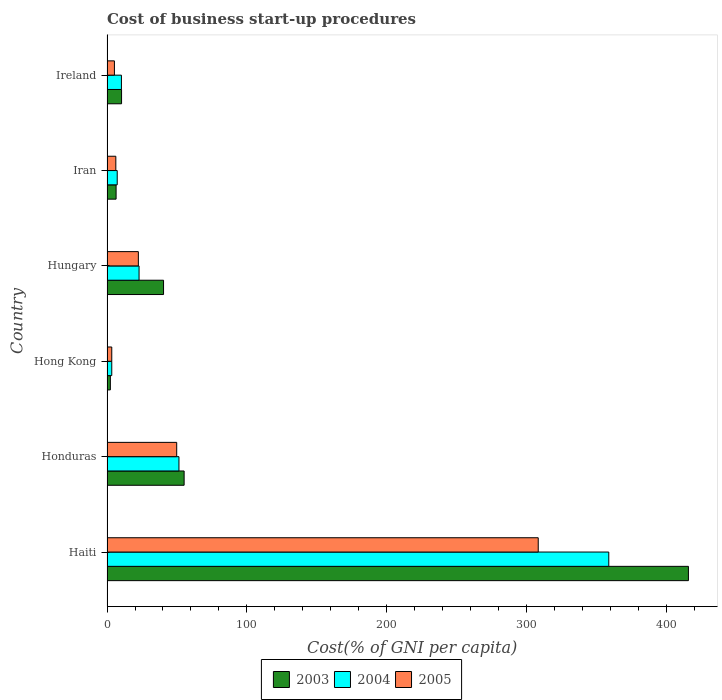How many different coloured bars are there?
Provide a short and direct response. 3. How many bars are there on the 5th tick from the bottom?
Your answer should be very brief. 3. What is the label of the 5th group of bars from the top?
Offer a very short reply. Honduras. In how many cases, is the number of bars for a given country not equal to the number of legend labels?
Keep it short and to the point. 0. Across all countries, what is the maximum cost of business start-up procedures in 2004?
Offer a terse response. 358.5. Across all countries, what is the minimum cost of business start-up procedures in 2003?
Provide a short and direct response. 2.4. In which country was the cost of business start-up procedures in 2005 maximum?
Ensure brevity in your answer.  Haiti. In which country was the cost of business start-up procedures in 2005 minimum?
Offer a terse response. Hong Kong. What is the total cost of business start-up procedures in 2003 in the graph?
Ensure brevity in your answer.  530.2. What is the difference between the cost of business start-up procedures in 2004 in Haiti and that in Honduras?
Provide a short and direct response. 307.1. What is the difference between the cost of business start-up procedures in 2004 in Honduras and the cost of business start-up procedures in 2003 in Hong Kong?
Provide a short and direct response. 49. What is the average cost of business start-up procedures in 2004 per country?
Offer a terse response. 75.63. What is the difference between the cost of business start-up procedures in 2005 and cost of business start-up procedures in 2003 in Honduras?
Keep it short and to the point. -5.3. In how many countries, is the cost of business start-up procedures in 2005 greater than 220 %?
Make the answer very short. 1. What is the ratio of the cost of business start-up procedures in 2004 in Hong Kong to that in Ireland?
Give a very brief answer. 0.33. What is the difference between the highest and the second highest cost of business start-up procedures in 2003?
Your answer should be very brief. 360.3. What is the difference between the highest and the lowest cost of business start-up procedures in 2005?
Give a very brief answer. 304.7. In how many countries, is the cost of business start-up procedures in 2003 greater than the average cost of business start-up procedures in 2003 taken over all countries?
Give a very brief answer. 1. Is the sum of the cost of business start-up procedures in 2003 in Haiti and Hungary greater than the maximum cost of business start-up procedures in 2005 across all countries?
Offer a very short reply. Yes. What does the 3rd bar from the top in Iran represents?
Keep it short and to the point. 2003. What does the 3rd bar from the bottom in Hong Kong represents?
Offer a very short reply. 2005. Is it the case that in every country, the sum of the cost of business start-up procedures in 2003 and cost of business start-up procedures in 2004 is greater than the cost of business start-up procedures in 2005?
Offer a very short reply. Yes. Does the graph contain any zero values?
Provide a short and direct response. No. How many legend labels are there?
Offer a terse response. 3. What is the title of the graph?
Your response must be concise. Cost of business start-up procedures. Does "1971" appear as one of the legend labels in the graph?
Make the answer very short. No. What is the label or title of the X-axis?
Ensure brevity in your answer.  Cost(% of GNI per capita). What is the Cost(% of GNI per capita) of 2003 in Haiti?
Make the answer very short. 415.4. What is the Cost(% of GNI per capita) of 2004 in Haiti?
Keep it short and to the point. 358.5. What is the Cost(% of GNI per capita) in 2005 in Haiti?
Offer a terse response. 308.1. What is the Cost(% of GNI per capita) of 2003 in Honduras?
Give a very brief answer. 55.1. What is the Cost(% of GNI per capita) in 2004 in Honduras?
Give a very brief answer. 51.4. What is the Cost(% of GNI per capita) of 2005 in Honduras?
Your answer should be compact. 49.8. What is the Cost(% of GNI per capita) in 2003 in Hong Kong?
Make the answer very short. 2.4. What is the Cost(% of GNI per capita) of 2003 in Hungary?
Your answer should be compact. 40.4. What is the Cost(% of GNI per capita) of 2004 in Hungary?
Your answer should be very brief. 22.9. What is the Cost(% of GNI per capita) of 2005 in Hungary?
Provide a succinct answer. 22.4. What is the Cost(% of GNI per capita) of 2004 in Iran?
Ensure brevity in your answer.  7.3. What is the Cost(% of GNI per capita) in 2003 in Ireland?
Provide a succinct answer. 10.4. What is the Cost(% of GNI per capita) of 2005 in Ireland?
Provide a succinct answer. 5.3. Across all countries, what is the maximum Cost(% of GNI per capita) in 2003?
Offer a terse response. 415.4. Across all countries, what is the maximum Cost(% of GNI per capita) in 2004?
Give a very brief answer. 358.5. Across all countries, what is the maximum Cost(% of GNI per capita) in 2005?
Provide a short and direct response. 308.1. Across all countries, what is the minimum Cost(% of GNI per capita) in 2004?
Offer a terse response. 3.4. What is the total Cost(% of GNI per capita) of 2003 in the graph?
Provide a succinct answer. 530.2. What is the total Cost(% of GNI per capita) in 2004 in the graph?
Your response must be concise. 453.8. What is the total Cost(% of GNI per capita) of 2005 in the graph?
Make the answer very short. 395.3. What is the difference between the Cost(% of GNI per capita) of 2003 in Haiti and that in Honduras?
Provide a succinct answer. 360.3. What is the difference between the Cost(% of GNI per capita) of 2004 in Haiti and that in Honduras?
Your response must be concise. 307.1. What is the difference between the Cost(% of GNI per capita) of 2005 in Haiti and that in Honduras?
Ensure brevity in your answer.  258.3. What is the difference between the Cost(% of GNI per capita) in 2003 in Haiti and that in Hong Kong?
Ensure brevity in your answer.  413. What is the difference between the Cost(% of GNI per capita) of 2004 in Haiti and that in Hong Kong?
Your answer should be compact. 355.1. What is the difference between the Cost(% of GNI per capita) of 2005 in Haiti and that in Hong Kong?
Your answer should be very brief. 304.7. What is the difference between the Cost(% of GNI per capita) of 2003 in Haiti and that in Hungary?
Make the answer very short. 375. What is the difference between the Cost(% of GNI per capita) of 2004 in Haiti and that in Hungary?
Offer a terse response. 335.6. What is the difference between the Cost(% of GNI per capita) in 2005 in Haiti and that in Hungary?
Provide a succinct answer. 285.7. What is the difference between the Cost(% of GNI per capita) of 2003 in Haiti and that in Iran?
Offer a very short reply. 408.9. What is the difference between the Cost(% of GNI per capita) in 2004 in Haiti and that in Iran?
Your response must be concise. 351.2. What is the difference between the Cost(% of GNI per capita) in 2005 in Haiti and that in Iran?
Your response must be concise. 301.8. What is the difference between the Cost(% of GNI per capita) of 2003 in Haiti and that in Ireland?
Your answer should be very brief. 405. What is the difference between the Cost(% of GNI per capita) of 2004 in Haiti and that in Ireland?
Provide a short and direct response. 348.2. What is the difference between the Cost(% of GNI per capita) of 2005 in Haiti and that in Ireland?
Your answer should be compact. 302.8. What is the difference between the Cost(% of GNI per capita) in 2003 in Honduras and that in Hong Kong?
Keep it short and to the point. 52.7. What is the difference between the Cost(% of GNI per capita) in 2004 in Honduras and that in Hong Kong?
Provide a short and direct response. 48. What is the difference between the Cost(% of GNI per capita) of 2005 in Honduras and that in Hong Kong?
Your answer should be compact. 46.4. What is the difference between the Cost(% of GNI per capita) in 2003 in Honduras and that in Hungary?
Your answer should be compact. 14.7. What is the difference between the Cost(% of GNI per capita) of 2004 in Honduras and that in Hungary?
Your response must be concise. 28.5. What is the difference between the Cost(% of GNI per capita) in 2005 in Honduras and that in Hungary?
Give a very brief answer. 27.4. What is the difference between the Cost(% of GNI per capita) of 2003 in Honduras and that in Iran?
Make the answer very short. 48.6. What is the difference between the Cost(% of GNI per capita) in 2004 in Honduras and that in Iran?
Keep it short and to the point. 44.1. What is the difference between the Cost(% of GNI per capita) of 2005 in Honduras and that in Iran?
Make the answer very short. 43.5. What is the difference between the Cost(% of GNI per capita) in 2003 in Honduras and that in Ireland?
Your response must be concise. 44.7. What is the difference between the Cost(% of GNI per capita) of 2004 in Honduras and that in Ireland?
Offer a terse response. 41.1. What is the difference between the Cost(% of GNI per capita) of 2005 in Honduras and that in Ireland?
Offer a very short reply. 44.5. What is the difference between the Cost(% of GNI per capita) of 2003 in Hong Kong and that in Hungary?
Offer a terse response. -38. What is the difference between the Cost(% of GNI per capita) of 2004 in Hong Kong and that in Hungary?
Offer a very short reply. -19.5. What is the difference between the Cost(% of GNI per capita) of 2005 in Hong Kong and that in Iran?
Your answer should be very brief. -2.9. What is the difference between the Cost(% of GNI per capita) of 2003 in Hong Kong and that in Ireland?
Offer a terse response. -8. What is the difference between the Cost(% of GNI per capita) of 2004 in Hong Kong and that in Ireland?
Provide a short and direct response. -6.9. What is the difference between the Cost(% of GNI per capita) in 2005 in Hong Kong and that in Ireland?
Offer a terse response. -1.9. What is the difference between the Cost(% of GNI per capita) of 2003 in Hungary and that in Iran?
Your answer should be compact. 33.9. What is the difference between the Cost(% of GNI per capita) in 2005 in Hungary and that in Iran?
Make the answer very short. 16.1. What is the difference between the Cost(% of GNI per capita) in 2005 in Hungary and that in Ireland?
Your answer should be very brief. 17.1. What is the difference between the Cost(% of GNI per capita) in 2005 in Iran and that in Ireland?
Provide a short and direct response. 1. What is the difference between the Cost(% of GNI per capita) of 2003 in Haiti and the Cost(% of GNI per capita) of 2004 in Honduras?
Provide a short and direct response. 364. What is the difference between the Cost(% of GNI per capita) in 2003 in Haiti and the Cost(% of GNI per capita) in 2005 in Honduras?
Offer a very short reply. 365.6. What is the difference between the Cost(% of GNI per capita) in 2004 in Haiti and the Cost(% of GNI per capita) in 2005 in Honduras?
Ensure brevity in your answer.  308.7. What is the difference between the Cost(% of GNI per capita) of 2003 in Haiti and the Cost(% of GNI per capita) of 2004 in Hong Kong?
Make the answer very short. 412. What is the difference between the Cost(% of GNI per capita) of 2003 in Haiti and the Cost(% of GNI per capita) of 2005 in Hong Kong?
Provide a succinct answer. 412. What is the difference between the Cost(% of GNI per capita) of 2004 in Haiti and the Cost(% of GNI per capita) of 2005 in Hong Kong?
Your answer should be very brief. 355.1. What is the difference between the Cost(% of GNI per capita) in 2003 in Haiti and the Cost(% of GNI per capita) in 2004 in Hungary?
Make the answer very short. 392.5. What is the difference between the Cost(% of GNI per capita) in 2003 in Haiti and the Cost(% of GNI per capita) in 2005 in Hungary?
Keep it short and to the point. 393. What is the difference between the Cost(% of GNI per capita) in 2004 in Haiti and the Cost(% of GNI per capita) in 2005 in Hungary?
Make the answer very short. 336.1. What is the difference between the Cost(% of GNI per capita) of 2003 in Haiti and the Cost(% of GNI per capita) of 2004 in Iran?
Give a very brief answer. 408.1. What is the difference between the Cost(% of GNI per capita) in 2003 in Haiti and the Cost(% of GNI per capita) in 2005 in Iran?
Give a very brief answer. 409.1. What is the difference between the Cost(% of GNI per capita) of 2004 in Haiti and the Cost(% of GNI per capita) of 2005 in Iran?
Keep it short and to the point. 352.2. What is the difference between the Cost(% of GNI per capita) in 2003 in Haiti and the Cost(% of GNI per capita) in 2004 in Ireland?
Ensure brevity in your answer.  405.1. What is the difference between the Cost(% of GNI per capita) in 2003 in Haiti and the Cost(% of GNI per capita) in 2005 in Ireland?
Ensure brevity in your answer.  410.1. What is the difference between the Cost(% of GNI per capita) of 2004 in Haiti and the Cost(% of GNI per capita) of 2005 in Ireland?
Offer a very short reply. 353.2. What is the difference between the Cost(% of GNI per capita) of 2003 in Honduras and the Cost(% of GNI per capita) of 2004 in Hong Kong?
Your response must be concise. 51.7. What is the difference between the Cost(% of GNI per capita) of 2003 in Honduras and the Cost(% of GNI per capita) of 2005 in Hong Kong?
Offer a very short reply. 51.7. What is the difference between the Cost(% of GNI per capita) in 2004 in Honduras and the Cost(% of GNI per capita) in 2005 in Hong Kong?
Keep it short and to the point. 48. What is the difference between the Cost(% of GNI per capita) of 2003 in Honduras and the Cost(% of GNI per capita) of 2004 in Hungary?
Your answer should be compact. 32.2. What is the difference between the Cost(% of GNI per capita) in 2003 in Honduras and the Cost(% of GNI per capita) in 2005 in Hungary?
Provide a succinct answer. 32.7. What is the difference between the Cost(% of GNI per capita) in 2003 in Honduras and the Cost(% of GNI per capita) in 2004 in Iran?
Offer a very short reply. 47.8. What is the difference between the Cost(% of GNI per capita) of 2003 in Honduras and the Cost(% of GNI per capita) of 2005 in Iran?
Your response must be concise. 48.8. What is the difference between the Cost(% of GNI per capita) in 2004 in Honduras and the Cost(% of GNI per capita) in 2005 in Iran?
Ensure brevity in your answer.  45.1. What is the difference between the Cost(% of GNI per capita) of 2003 in Honduras and the Cost(% of GNI per capita) of 2004 in Ireland?
Give a very brief answer. 44.8. What is the difference between the Cost(% of GNI per capita) in 2003 in Honduras and the Cost(% of GNI per capita) in 2005 in Ireland?
Make the answer very short. 49.8. What is the difference between the Cost(% of GNI per capita) in 2004 in Honduras and the Cost(% of GNI per capita) in 2005 in Ireland?
Make the answer very short. 46.1. What is the difference between the Cost(% of GNI per capita) in 2003 in Hong Kong and the Cost(% of GNI per capita) in 2004 in Hungary?
Make the answer very short. -20.5. What is the difference between the Cost(% of GNI per capita) in 2003 in Hong Kong and the Cost(% of GNI per capita) in 2005 in Hungary?
Your response must be concise. -20. What is the difference between the Cost(% of GNI per capita) of 2003 in Hong Kong and the Cost(% of GNI per capita) of 2004 in Iran?
Make the answer very short. -4.9. What is the difference between the Cost(% of GNI per capita) of 2004 in Hong Kong and the Cost(% of GNI per capita) of 2005 in Iran?
Ensure brevity in your answer.  -2.9. What is the difference between the Cost(% of GNI per capita) in 2003 in Hong Kong and the Cost(% of GNI per capita) in 2004 in Ireland?
Give a very brief answer. -7.9. What is the difference between the Cost(% of GNI per capita) of 2003 in Hong Kong and the Cost(% of GNI per capita) of 2005 in Ireland?
Ensure brevity in your answer.  -2.9. What is the difference between the Cost(% of GNI per capita) of 2004 in Hong Kong and the Cost(% of GNI per capita) of 2005 in Ireland?
Your answer should be compact. -1.9. What is the difference between the Cost(% of GNI per capita) in 2003 in Hungary and the Cost(% of GNI per capita) in 2004 in Iran?
Give a very brief answer. 33.1. What is the difference between the Cost(% of GNI per capita) in 2003 in Hungary and the Cost(% of GNI per capita) in 2005 in Iran?
Provide a succinct answer. 34.1. What is the difference between the Cost(% of GNI per capita) of 2004 in Hungary and the Cost(% of GNI per capita) of 2005 in Iran?
Provide a succinct answer. 16.6. What is the difference between the Cost(% of GNI per capita) of 2003 in Hungary and the Cost(% of GNI per capita) of 2004 in Ireland?
Offer a very short reply. 30.1. What is the difference between the Cost(% of GNI per capita) in 2003 in Hungary and the Cost(% of GNI per capita) in 2005 in Ireland?
Your response must be concise. 35.1. What is the difference between the Cost(% of GNI per capita) of 2004 in Hungary and the Cost(% of GNI per capita) of 2005 in Ireland?
Your response must be concise. 17.6. What is the difference between the Cost(% of GNI per capita) of 2003 in Iran and the Cost(% of GNI per capita) of 2004 in Ireland?
Make the answer very short. -3.8. What is the difference between the Cost(% of GNI per capita) of 2004 in Iran and the Cost(% of GNI per capita) of 2005 in Ireland?
Provide a succinct answer. 2. What is the average Cost(% of GNI per capita) of 2003 per country?
Provide a short and direct response. 88.37. What is the average Cost(% of GNI per capita) in 2004 per country?
Provide a succinct answer. 75.63. What is the average Cost(% of GNI per capita) in 2005 per country?
Provide a short and direct response. 65.88. What is the difference between the Cost(% of GNI per capita) of 2003 and Cost(% of GNI per capita) of 2004 in Haiti?
Keep it short and to the point. 56.9. What is the difference between the Cost(% of GNI per capita) in 2003 and Cost(% of GNI per capita) in 2005 in Haiti?
Ensure brevity in your answer.  107.3. What is the difference between the Cost(% of GNI per capita) in 2004 and Cost(% of GNI per capita) in 2005 in Haiti?
Your answer should be very brief. 50.4. What is the difference between the Cost(% of GNI per capita) of 2003 and Cost(% of GNI per capita) of 2004 in Honduras?
Provide a succinct answer. 3.7. What is the difference between the Cost(% of GNI per capita) of 2003 and Cost(% of GNI per capita) of 2005 in Hong Kong?
Your response must be concise. -1. What is the difference between the Cost(% of GNI per capita) in 2003 and Cost(% of GNI per capita) in 2004 in Iran?
Make the answer very short. -0.8. What is the difference between the Cost(% of GNI per capita) in 2003 and Cost(% of GNI per capita) in 2005 in Iran?
Give a very brief answer. 0.2. What is the difference between the Cost(% of GNI per capita) of 2004 and Cost(% of GNI per capita) of 2005 in Iran?
Your answer should be very brief. 1. What is the ratio of the Cost(% of GNI per capita) of 2003 in Haiti to that in Honduras?
Your answer should be very brief. 7.54. What is the ratio of the Cost(% of GNI per capita) of 2004 in Haiti to that in Honduras?
Your response must be concise. 6.97. What is the ratio of the Cost(% of GNI per capita) of 2005 in Haiti to that in Honduras?
Provide a short and direct response. 6.19. What is the ratio of the Cost(% of GNI per capita) of 2003 in Haiti to that in Hong Kong?
Your answer should be very brief. 173.08. What is the ratio of the Cost(% of GNI per capita) of 2004 in Haiti to that in Hong Kong?
Make the answer very short. 105.44. What is the ratio of the Cost(% of GNI per capita) in 2005 in Haiti to that in Hong Kong?
Your response must be concise. 90.62. What is the ratio of the Cost(% of GNI per capita) of 2003 in Haiti to that in Hungary?
Your answer should be compact. 10.28. What is the ratio of the Cost(% of GNI per capita) of 2004 in Haiti to that in Hungary?
Your answer should be compact. 15.65. What is the ratio of the Cost(% of GNI per capita) in 2005 in Haiti to that in Hungary?
Your response must be concise. 13.75. What is the ratio of the Cost(% of GNI per capita) in 2003 in Haiti to that in Iran?
Your answer should be very brief. 63.91. What is the ratio of the Cost(% of GNI per capita) in 2004 in Haiti to that in Iran?
Ensure brevity in your answer.  49.11. What is the ratio of the Cost(% of GNI per capita) of 2005 in Haiti to that in Iran?
Ensure brevity in your answer.  48.9. What is the ratio of the Cost(% of GNI per capita) in 2003 in Haiti to that in Ireland?
Your response must be concise. 39.94. What is the ratio of the Cost(% of GNI per capita) of 2004 in Haiti to that in Ireland?
Offer a very short reply. 34.81. What is the ratio of the Cost(% of GNI per capita) in 2005 in Haiti to that in Ireland?
Offer a very short reply. 58.13. What is the ratio of the Cost(% of GNI per capita) in 2003 in Honduras to that in Hong Kong?
Your response must be concise. 22.96. What is the ratio of the Cost(% of GNI per capita) of 2004 in Honduras to that in Hong Kong?
Ensure brevity in your answer.  15.12. What is the ratio of the Cost(% of GNI per capita) in 2005 in Honduras to that in Hong Kong?
Make the answer very short. 14.65. What is the ratio of the Cost(% of GNI per capita) of 2003 in Honduras to that in Hungary?
Provide a succinct answer. 1.36. What is the ratio of the Cost(% of GNI per capita) in 2004 in Honduras to that in Hungary?
Offer a terse response. 2.24. What is the ratio of the Cost(% of GNI per capita) of 2005 in Honduras to that in Hungary?
Give a very brief answer. 2.22. What is the ratio of the Cost(% of GNI per capita) in 2003 in Honduras to that in Iran?
Your answer should be compact. 8.48. What is the ratio of the Cost(% of GNI per capita) in 2004 in Honduras to that in Iran?
Your answer should be compact. 7.04. What is the ratio of the Cost(% of GNI per capita) in 2005 in Honduras to that in Iran?
Keep it short and to the point. 7.9. What is the ratio of the Cost(% of GNI per capita) of 2003 in Honduras to that in Ireland?
Your answer should be very brief. 5.3. What is the ratio of the Cost(% of GNI per capita) in 2004 in Honduras to that in Ireland?
Provide a short and direct response. 4.99. What is the ratio of the Cost(% of GNI per capita) in 2005 in Honduras to that in Ireland?
Your answer should be compact. 9.4. What is the ratio of the Cost(% of GNI per capita) in 2003 in Hong Kong to that in Hungary?
Offer a terse response. 0.06. What is the ratio of the Cost(% of GNI per capita) of 2004 in Hong Kong to that in Hungary?
Your answer should be compact. 0.15. What is the ratio of the Cost(% of GNI per capita) of 2005 in Hong Kong to that in Hungary?
Your answer should be compact. 0.15. What is the ratio of the Cost(% of GNI per capita) of 2003 in Hong Kong to that in Iran?
Provide a short and direct response. 0.37. What is the ratio of the Cost(% of GNI per capita) in 2004 in Hong Kong to that in Iran?
Your response must be concise. 0.47. What is the ratio of the Cost(% of GNI per capita) in 2005 in Hong Kong to that in Iran?
Keep it short and to the point. 0.54. What is the ratio of the Cost(% of GNI per capita) in 2003 in Hong Kong to that in Ireland?
Your answer should be very brief. 0.23. What is the ratio of the Cost(% of GNI per capita) of 2004 in Hong Kong to that in Ireland?
Your answer should be compact. 0.33. What is the ratio of the Cost(% of GNI per capita) of 2005 in Hong Kong to that in Ireland?
Your answer should be very brief. 0.64. What is the ratio of the Cost(% of GNI per capita) of 2003 in Hungary to that in Iran?
Keep it short and to the point. 6.22. What is the ratio of the Cost(% of GNI per capita) of 2004 in Hungary to that in Iran?
Make the answer very short. 3.14. What is the ratio of the Cost(% of GNI per capita) in 2005 in Hungary to that in Iran?
Provide a short and direct response. 3.56. What is the ratio of the Cost(% of GNI per capita) in 2003 in Hungary to that in Ireland?
Your response must be concise. 3.88. What is the ratio of the Cost(% of GNI per capita) in 2004 in Hungary to that in Ireland?
Provide a short and direct response. 2.22. What is the ratio of the Cost(% of GNI per capita) in 2005 in Hungary to that in Ireland?
Your response must be concise. 4.23. What is the ratio of the Cost(% of GNI per capita) of 2004 in Iran to that in Ireland?
Keep it short and to the point. 0.71. What is the ratio of the Cost(% of GNI per capita) of 2005 in Iran to that in Ireland?
Give a very brief answer. 1.19. What is the difference between the highest and the second highest Cost(% of GNI per capita) in 2003?
Your answer should be compact. 360.3. What is the difference between the highest and the second highest Cost(% of GNI per capita) of 2004?
Your answer should be very brief. 307.1. What is the difference between the highest and the second highest Cost(% of GNI per capita) of 2005?
Offer a very short reply. 258.3. What is the difference between the highest and the lowest Cost(% of GNI per capita) of 2003?
Offer a very short reply. 413. What is the difference between the highest and the lowest Cost(% of GNI per capita) in 2004?
Your answer should be compact. 355.1. What is the difference between the highest and the lowest Cost(% of GNI per capita) in 2005?
Give a very brief answer. 304.7. 